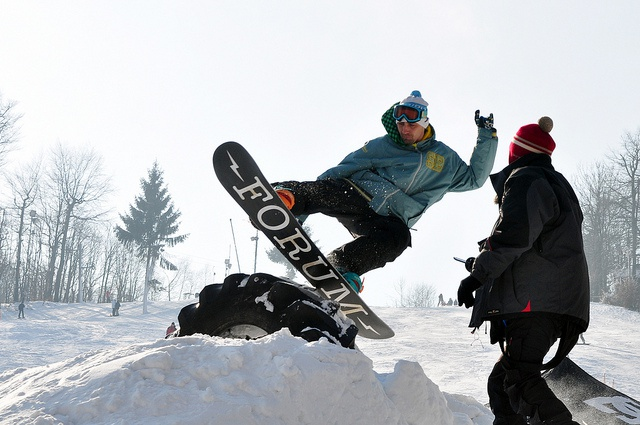Describe the objects in this image and their specific colors. I can see people in white, black, maroon, and gray tones, people in white, black, blue, gray, and darkblue tones, snowboard in white, black, gray, darkgray, and lightgray tones, people in white, gray, darkgray, and black tones, and people in white, gray, and darkgray tones in this image. 